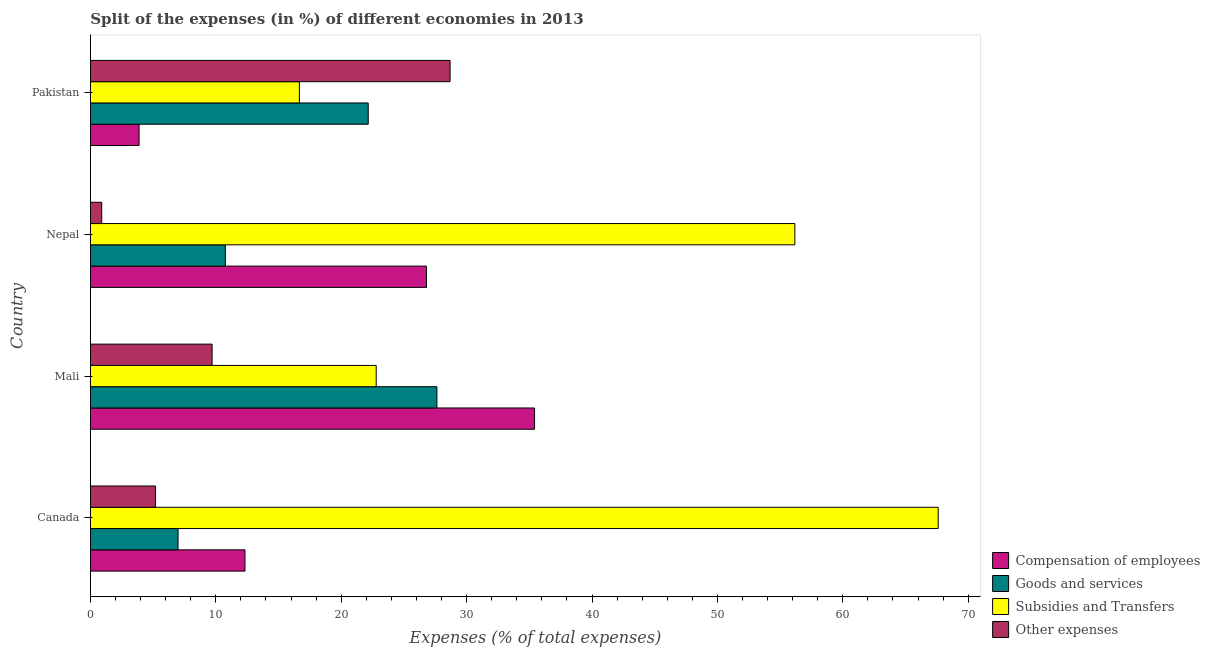How many different coloured bars are there?
Your answer should be compact. 4. How many groups of bars are there?
Provide a succinct answer. 4. Are the number of bars per tick equal to the number of legend labels?
Your answer should be very brief. Yes. How many bars are there on the 2nd tick from the bottom?
Provide a succinct answer. 4. What is the label of the 1st group of bars from the top?
Give a very brief answer. Pakistan. In how many cases, is the number of bars for a given country not equal to the number of legend labels?
Your answer should be compact. 0. What is the percentage of amount spent on subsidies in Pakistan?
Make the answer very short. 16.66. Across all countries, what is the maximum percentage of amount spent on subsidies?
Provide a succinct answer. 67.61. Across all countries, what is the minimum percentage of amount spent on goods and services?
Make the answer very short. 6.99. In which country was the percentage of amount spent on subsidies maximum?
Provide a short and direct response. Canada. What is the total percentage of amount spent on goods and services in the graph?
Provide a succinct answer. 67.55. What is the difference between the percentage of amount spent on compensation of employees in Canada and that in Nepal?
Ensure brevity in your answer.  -14.48. What is the difference between the percentage of amount spent on compensation of employees in Mali and the percentage of amount spent on other expenses in Nepal?
Your answer should be compact. 34.52. What is the average percentage of amount spent on subsidies per country?
Offer a terse response. 40.81. What is the difference between the percentage of amount spent on other expenses and percentage of amount spent on compensation of employees in Pakistan?
Your response must be concise. 24.8. What is the ratio of the percentage of amount spent on other expenses in Mali to that in Nepal?
Your response must be concise. 10.73. Is the difference between the percentage of amount spent on subsidies in Canada and Nepal greater than the difference between the percentage of amount spent on goods and services in Canada and Nepal?
Give a very brief answer. Yes. What is the difference between the highest and the second highest percentage of amount spent on goods and services?
Make the answer very short. 5.48. What is the difference between the highest and the lowest percentage of amount spent on subsidies?
Offer a very short reply. 50.94. Is it the case that in every country, the sum of the percentage of amount spent on goods and services and percentage of amount spent on compensation of employees is greater than the sum of percentage of amount spent on other expenses and percentage of amount spent on subsidies?
Provide a succinct answer. Yes. What does the 3rd bar from the top in Nepal represents?
Your answer should be very brief. Goods and services. What does the 3rd bar from the bottom in Nepal represents?
Make the answer very short. Subsidies and Transfers. How many bars are there?
Make the answer very short. 16. Are all the bars in the graph horizontal?
Offer a very short reply. Yes. What is the difference between two consecutive major ticks on the X-axis?
Provide a succinct answer. 10. Does the graph contain any zero values?
Offer a terse response. No. What is the title of the graph?
Provide a succinct answer. Split of the expenses (in %) of different economies in 2013. What is the label or title of the X-axis?
Ensure brevity in your answer.  Expenses (% of total expenses). What is the label or title of the Y-axis?
Keep it short and to the point. Country. What is the Expenses (% of total expenses) of Compensation of employees in Canada?
Offer a terse response. 12.33. What is the Expenses (% of total expenses) in Goods and services in Canada?
Provide a succinct answer. 6.99. What is the Expenses (% of total expenses) of Subsidies and Transfers in Canada?
Your answer should be compact. 67.61. What is the Expenses (% of total expenses) in Other expenses in Canada?
Ensure brevity in your answer.  5.2. What is the Expenses (% of total expenses) in Compensation of employees in Mali?
Provide a succinct answer. 35.42. What is the Expenses (% of total expenses) of Goods and services in Mali?
Offer a very short reply. 27.63. What is the Expenses (% of total expenses) of Subsidies and Transfers in Mali?
Offer a terse response. 22.79. What is the Expenses (% of total expenses) of Other expenses in Mali?
Give a very brief answer. 9.71. What is the Expenses (% of total expenses) in Compensation of employees in Nepal?
Your answer should be very brief. 26.8. What is the Expenses (% of total expenses) of Goods and services in Nepal?
Give a very brief answer. 10.76. What is the Expenses (% of total expenses) in Subsidies and Transfers in Nepal?
Your response must be concise. 56.17. What is the Expenses (% of total expenses) in Other expenses in Nepal?
Make the answer very short. 0.9. What is the Expenses (% of total expenses) of Compensation of employees in Pakistan?
Keep it short and to the point. 3.88. What is the Expenses (% of total expenses) of Goods and services in Pakistan?
Ensure brevity in your answer.  22.16. What is the Expenses (% of total expenses) of Subsidies and Transfers in Pakistan?
Give a very brief answer. 16.66. What is the Expenses (% of total expenses) in Other expenses in Pakistan?
Keep it short and to the point. 28.68. Across all countries, what is the maximum Expenses (% of total expenses) of Compensation of employees?
Offer a very short reply. 35.42. Across all countries, what is the maximum Expenses (% of total expenses) of Goods and services?
Offer a terse response. 27.63. Across all countries, what is the maximum Expenses (% of total expenses) in Subsidies and Transfers?
Ensure brevity in your answer.  67.61. Across all countries, what is the maximum Expenses (% of total expenses) in Other expenses?
Make the answer very short. 28.68. Across all countries, what is the minimum Expenses (% of total expenses) of Compensation of employees?
Give a very brief answer. 3.88. Across all countries, what is the minimum Expenses (% of total expenses) of Goods and services?
Give a very brief answer. 6.99. Across all countries, what is the minimum Expenses (% of total expenses) of Subsidies and Transfers?
Your answer should be compact. 16.66. Across all countries, what is the minimum Expenses (% of total expenses) of Other expenses?
Your answer should be compact. 0.9. What is the total Expenses (% of total expenses) of Compensation of employees in the graph?
Your answer should be compact. 78.44. What is the total Expenses (% of total expenses) of Goods and services in the graph?
Your answer should be compact. 67.55. What is the total Expenses (% of total expenses) of Subsidies and Transfers in the graph?
Make the answer very short. 163.24. What is the total Expenses (% of total expenses) in Other expenses in the graph?
Keep it short and to the point. 44.49. What is the difference between the Expenses (% of total expenses) of Compensation of employees in Canada and that in Mali?
Keep it short and to the point. -23.09. What is the difference between the Expenses (% of total expenses) of Goods and services in Canada and that in Mali?
Make the answer very short. -20.64. What is the difference between the Expenses (% of total expenses) of Subsidies and Transfers in Canada and that in Mali?
Offer a very short reply. 44.81. What is the difference between the Expenses (% of total expenses) of Other expenses in Canada and that in Mali?
Provide a short and direct response. -4.51. What is the difference between the Expenses (% of total expenses) in Compensation of employees in Canada and that in Nepal?
Your response must be concise. -14.48. What is the difference between the Expenses (% of total expenses) of Goods and services in Canada and that in Nepal?
Provide a succinct answer. -3.77. What is the difference between the Expenses (% of total expenses) in Subsidies and Transfers in Canada and that in Nepal?
Keep it short and to the point. 11.43. What is the difference between the Expenses (% of total expenses) of Other expenses in Canada and that in Nepal?
Give a very brief answer. 4.29. What is the difference between the Expenses (% of total expenses) of Compensation of employees in Canada and that in Pakistan?
Offer a terse response. 8.44. What is the difference between the Expenses (% of total expenses) in Goods and services in Canada and that in Pakistan?
Keep it short and to the point. -15.17. What is the difference between the Expenses (% of total expenses) of Subsidies and Transfers in Canada and that in Pakistan?
Your answer should be compact. 50.94. What is the difference between the Expenses (% of total expenses) in Other expenses in Canada and that in Pakistan?
Your response must be concise. -23.49. What is the difference between the Expenses (% of total expenses) of Compensation of employees in Mali and that in Nepal?
Your answer should be compact. 8.62. What is the difference between the Expenses (% of total expenses) in Goods and services in Mali and that in Nepal?
Provide a short and direct response. 16.87. What is the difference between the Expenses (% of total expenses) of Subsidies and Transfers in Mali and that in Nepal?
Your answer should be compact. -33.38. What is the difference between the Expenses (% of total expenses) of Other expenses in Mali and that in Nepal?
Keep it short and to the point. 8.8. What is the difference between the Expenses (% of total expenses) in Compensation of employees in Mali and that in Pakistan?
Provide a succinct answer. 31.54. What is the difference between the Expenses (% of total expenses) in Goods and services in Mali and that in Pakistan?
Offer a very short reply. 5.48. What is the difference between the Expenses (% of total expenses) in Subsidies and Transfers in Mali and that in Pakistan?
Ensure brevity in your answer.  6.13. What is the difference between the Expenses (% of total expenses) of Other expenses in Mali and that in Pakistan?
Your response must be concise. -18.98. What is the difference between the Expenses (% of total expenses) in Compensation of employees in Nepal and that in Pakistan?
Offer a very short reply. 22.92. What is the difference between the Expenses (% of total expenses) of Goods and services in Nepal and that in Pakistan?
Keep it short and to the point. -11.39. What is the difference between the Expenses (% of total expenses) of Subsidies and Transfers in Nepal and that in Pakistan?
Provide a succinct answer. 39.51. What is the difference between the Expenses (% of total expenses) of Other expenses in Nepal and that in Pakistan?
Provide a short and direct response. -27.78. What is the difference between the Expenses (% of total expenses) in Compensation of employees in Canada and the Expenses (% of total expenses) in Goods and services in Mali?
Offer a terse response. -15.31. What is the difference between the Expenses (% of total expenses) of Compensation of employees in Canada and the Expenses (% of total expenses) of Subsidies and Transfers in Mali?
Provide a short and direct response. -10.46. What is the difference between the Expenses (% of total expenses) of Compensation of employees in Canada and the Expenses (% of total expenses) of Other expenses in Mali?
Provide a short and direct response. 2.62. What is the difference between the Expenses (% of total expenses) in Goods and services in Canada and the Expenses (% of total expenses) in Subsidies and Transfers in Mali?
Give a very brief answer. -15.8. What is the difference between the Expenses (% of total expenses) of Goods and services in Canada and the Expenses (% of total expenses) of Other expenses in Mali?
Your answer should be very brief. -2.71. What is the difference between the Expenses (% of total expenses) in Subsidies and Transfers in Canada and the Expenses (% of total expenses) in Other expenses in Mali?
Provide a succinct answer. 57.9. What is the difference between the Expenses (% of total expenses) of Compensation of employees in Canada and the Expenses (% of total expenses) of Goods and services in Nepal?
Your answer should be very brief. 1.56. What is the difference between the Expenses (% of total expenses) of Compensation of employees in Canada and the Expenses (% of total expenses) of Subsidies and Transfers in Nepal?
Offer a terse response. -43.85. What is the difference between the Expenses (% of total expenses) of Compensation of employees in Canada and the Expenses (% of total expenses) of Other expenses in Nepal?
Your answer should be compact. 11.42. What is the difference between the Expenses (% of total expenses) of Goods and services in Canada and the Expenses (% of total expenses) of Subsidies and Transfers in Nepal?
Give a very brief answer. -49.18. What is the difference between the Expenses (% of total expenses) of Goods and services in Canada and the Expenses (% of total expenses) of Other expenses in Nepal?
Ensure brevity in your answer.  6.09. What is the difference between the Expenses (% of total expenses) in Subsidies and Transfers in Canada and the Expenses (% of total expenses) in Other expenses in Nepal?
Provide a succinct answer. 66.7. What is the difference between the Expenses (% of total expenses) of Compensation of employees in Canada and the Expenses (% of total expenses) of Goods and services in Pakistan?
Give a very brief answer. -9.83. What is the difference between the Expenses (% of total expenses) in Compensation of employees in Canada and the Expenses (% of total expenses) in Subsidies and Transfers in Pakistan?
Keep it short and to the point. -4.34. What is the difference between the Expenses (% of total expenses) of Compensation of employees in Canada and the Expenses (% of total expenses) of Other expenses in Pakistan?
Your answer should be compact. -16.36. What is the difference between the Expenses (% of total expenses) in Goods and services in Canada and the Expenses (% of total expenses) in Subsidies and Transfers in Pakistan?
Provide a succinct answer. -9.67. What is the difference between the Expenses (% of total expenses) in Goods and services in Canada and the Expenses (% of total expenses) in Other expenses in Pakistan?
Offer a very short reply. -21.69. What is the difference between the Expenses (% of total expenses) of Subsidies and Transfers in Canada and the Expenses (% of total expenses) of Other expenses in Pakistan?
Offer a terse response. 38.92. What is the difference between the Expenses (% of total expenses) in Compensation of employees in Mali and the Expenses (% of total expenses) in Goods and services in Nepal?
Give a very brief answer. 24.66. What is the difference between the Expenses (% of total expenses) of Compensation of employees in Mali and the Expenses (% of total expenses) of Subsidies and Transfers in Nepal?
Keep it short and to the point. -20.75. What is the difference between the Expenses (% of total expenses) of Compensation of employees in Mali and the Expenses (% of total expenses) of Other expenses in Nepal?
Make the answer very short. 34.52. What is the difference between the Expenses (% of total expenses) of Goods and services in Mali and the Expenses (% of total expenses) of Subsidies and Transfers in Nepal?
Provide a short and direct response. -28.54. What is the difference between the Expenses (% of total expenses) of Goods and services in Mali and the Expenses (% of total expenses) of Other expenses in Nepal?
Ensure brevity in your answer.  26.73. What is the difference between the Expenses (% of total expenses) of Subsidies and Transfers in Mali and the Expenses (% of total expenses) of Other expenses in Nepal?
Give a very brief answer. 21.89. What is the difference between the Expenses (% of total expenses) in Compensation of employees in Mali and the Expenses (% of total expenses) in Goods and services in Pakistan?
Your response must be concise. 13.26. What is the difference between the Expenses (% of total expenses) in Compensation of employees in Mali and the Expenses (% of total expenses) in Subsidies and Transfers in Pakistan?
Provide a short and direct response. 18.76. What is the difference between the Expenses (% of total expenses) of Compensation of employees in Mali and the Expenses (% of total expenses) of Other expenses in Pakistan?
Your answer should be very brief. 6.74. What is the difference between the Expenses (% of total expenses) in Goods and services in Mali and the Expenses (% of total expenses) in Subsidies and Transfers in Pakistan?
Keep it short and to the point. 10.97. What is the difference between the Expenses (% of total expenses) of Goods and services in Mali and the Expenses (% of total expenses) of Other expenses in Pakistan?
Offer a terse response. -1.05. What is the difference between the Expenses (% of total expenses) in Subsidies and Transfers in Mali and the Expenses (% of total expenses) in Other expenses in Pakistan?
Your response must be concise. -5.89. What is the difference between the Expenses (% of total expenses) in Compensation of employees in Nepal and the Expenses (% of total expenses) in Goods and services in Pakistan?
Offer a very short reply. 4.65. What is the difference between the Expenses (% of total expenses) of Compensation of employees in Nepal and the Expenses (% of total expenses) of Subsidies and Transfers in Pakistan?
Offer a very short reply. 10.14. What is the difference between the Expenses (% of total expenses) in Compensation of employees in Nepal and the Expenses (% of total expenses) in Other expenses in Pakistan?
Ensure brevity in your answer.  -1.88. What is the difference between the Expenses (% of total expenses) in Goods and services in Nepal and the Expenses (% of total expenses) in Subsidies and Transfers in Pakistan?
Your answer should be compact. -5.9. What is the difference between the Expenses (% of total expenses) of Goods and services in Nepal and the Expenses (% of total expenses) of Other expenses in Pakistan?
Your response must be concise. -17.92. What is the difference between the Expenses (% of total expenses) of Subsidies and Transfers in Nepal and the Expenses (% of total expenses) of Other expenses in Pakistan?
Give a very brief answer. 27.49. What is the average Expenses (% of total expenses) in Compensation of employees per country?
Your answer should be very brief. 19.61. What is the average Expenses (% of total expenses) of Goods and services per country?
Provide a short and direct response. 16.89. What is the average Expenses (% of total expenses) in Subsidies and Transfers per country?
Offer a very short reply. 40.81. What is the average Expenses (% of total expenses) in Other expenses per country?
Your answer should be compact. 11.12. What is the difference between the Expenses (% of total expenses) in Compensation of employees and Expenses (% of total expenses) in Goods and services in Canada?
Provide a succinct answer. 5.34. What is the difference between the Expenses (% of total expenses) in Compensation of employees and Expenses (% of total expenses) in Subsidies and Transfers in Canada?
Give a very brief answer. -55.28. What is the difference between the Expenses (% of total expenses) in Compensation of employees and Expenses (% of total expenses) in Other expenses in Canada?
Provide a short and direct response. 7.13. What is the difference between the Expenses (% of total expenses) in Goods and services and Expenses (% of total expenses) in Subsidies and Transfers in Canada?
Offer a terse response. -60.61. What is the difference between the Expenses (% of total expenses) in Goods and services and Expenses (% of total expenses) in Other expenses in Canada?
Make the answer very short. 1.8. What is the difference between the Expenses (% of total expenses) in Subsidies and Transfers and Expenses (% of total expenses) in Other expenses in Canada?
Provide a succinct answer. 62.41. What is the difference between the Expenses (% of total expenses) of Compensation of employees and Expenses (% of total expenses) of Goods and services in Mali?
Your answer should be compact. 7.79. What is the difference between the Expenses (% of total expenses) of Compensation of employees and Expenses (% of total expenses) of Subsidies and Transfers in Mali?
Your answer should be compact. 12.63. What is the difference between the Expenses (% of total expenses) of Compensation of employees and Expenses (% of total expenses) of Other expenses in Mali?
Ensure brevity in your answer.  25.71. What is the difference between the Expenses (% of total expenses) of Goods and services and Expenses (% of total expenses) of Subsidies and Transfers in Mali?
Your response must be concise. 4.84. What is the difference between the Expenses (% of total expenses) of Goods and services and Expenses (% of total expenses) of Other expenses in Mali?
Your answer should be compact. 17.93. What is the difference between the Expenses (% of total expenses) of Subsidies and Transfers and Expenses (% of total expenses) of Other expenses in Mali?
Make the answer very short. 13.09. What is the difference between the Expenses (% of total expenses) in Compensation of employees and Expenses (% of total expenses) in Goods and services in Nepal?
Provide a succinct answer. 16.04. What is the difference between the Expenses (% of total expenses) of Compensation of employees and Expenses (% of total expenses) of Subsidies and Transfers in Nepal?
Make the answer very short. -29.37. What is the difference between the Expenses (% of total expenses) in Compensation of employees and Expenses (% of total expenses) in Other expenses in Nepal?
Your response must be concise. 25.9. What is the difference between the Expenses (% of total expenses) of Goods and services and Expenses (% of total expenses) of Subsidies and Transfers in Nepal?
Your answer should be compact. -45.41. What is the difference between the Expenses (% of total expenses) of Goods and services and Expenses (% of total expenses) of Other expenses in Nepal?
Keep it short and to the point. 9.86. What is the difference between the Expenses (% of total expenses) in Subsidies and Transfers and Expenses (% of total expenses) in Other expenses in Nepal?
Your response must be concise. 55.27. What is the difference between the Expenses (% of total expenses) in Compensation of employees and Expenses (% of total expenses) in Goods and services in Pakistan?
Make the answer very short. -18.27. What is the difference between the Expenses (% of total expenses) of Compensation of employees and Expenses (% of total expenses) of Subsidies and Transfers in Pakistan?
Your response must be concise. -12.78. What is the difference between the Expenses (% of total expenses) in Compensation of employees and Expenses (% of total expenses) in Other expenses in Pakistan?
Your answer should be compact. -24.8. What is the difference between the Expenses (% of total expenses) in Goods and services and Expenses (% of total expenses) in Subsidies and Transfers in Pakistan?
Your answer should be compact. 5.49. What is the difference between the Expenses (% of total expenses) in Goods and services and Expenses (% of total expenses) in Other expenses in Pakistan?
Your answer should be very brief. -6.53. What is the difference between the Expenses (% of total expenses) in Subsidies and Transfers and Expenses (% of total expenses) in Other expenses in Pakistan?
Provide a succinct answer. -12.02. What is the ratio of the Expenses (% of total expenses) of Compensation of employees in Canada to that in Mali?
Provide a short and direct response. 0.35. What is the ratio of the Expenses (% of total expenses) of Goods and services in Canada to that in Mali?
Your response must be concise. 0.25. What is the ratio of the Expenses (% of total expenses) of Subsidies and Transfers in Canada to that in Mali?
Give a very brief answer. 2.97. What is the ratio of the Expenses (% of total expenses) in Other expenses in Canada to that in Mali?
Your response must be concise. 0.54. What is the ratio of the Expenses (% of total expenses) of Compensation of employees in Canada to that in Nepal?
Your answer should be compact. 0.46. What is the ratio of the Expenses (% of total expenses) of Goods and services in Canada to that in Nepal?
Ensure brevity in your answer.  0.65. What is the ratio of the Expenses (% of total expenses) in Subsidies and Transfers in Canada to that in Nepal?
Offer a very short reply. 1.2. What is the ratio of the Expenses (% of total expenses) of Other expenses in Canada to that in Nepal?
Ensure brevity in your answer.  5.74. What is the ratio of the Expenses (% of total expenses) in Compensation of employees in Canada to that in Pakistan?
Keep it short and to the point. 3.17. What is the ratio of the Expenses (% of total expenses) in Goods and services in Canada to that in Pakistan?
Keep it short and to the point. 0.32. What is the ratio of the Expenses (% of total expenses) in Subsidies and Transfers in Canada to that in Pakistan?
Your answer should be compact. 4.06. What is the ratio of the Expenses (% of total expenses) of Other expenses in Canada to that in Pakistan?
Offer a very short reply. 0.18. What is the ratio of the Expenses (% of total expenses) in Compensation of employees in Mali to that in Nepal?
Provide a succinct answer. 1.32. What is the ratio of the Expenses (% of total expenses) in Goods and services in Mali to that in Nepal?
Your answer should be very brief. 2.57. What is the ratio of the Expenses (% of total expenses) of Subsidies and Transfers in Mali to that in Nepal?
Your answer should be compact. 0.41. What is the ratio of the Expenses (% of total expenses) of Other expenses in Mali to that in Nepal?
Provide a succinct answer. 10.73. What is the ratio of the Expenses (% of total expenses) in Compensation of employees in Mali to that in Pakistan?
Your response must be concise. 9.12. What is the ratio of the Expenses (% of total expenses) of Goods and services in Mali to that in Pakistan?
Offer a terse response. 1.25. What is the ratio of the Expenses (% of total expenses) in Subsidies and Transfers in Mali to that in Pakistan?
Give a very brief answer. 1.37. What is the ratio of the Expenses (% of total expenses) of Other expenses in Mali to that in Pakistan?
Keep it short and to the point. 0.34. What is the ratio of the Expenses (% of total expenses) of Compensation of employees in Nepal to that in Pakistan?
Offer a very short reply. 6.9. What is the ratio of the Expenses (% of total expenses) in Goods and services in Nepal to that in Pakistan?
Keep it short and to the point. 0.49. What is the ratio of the Expenses (% of total expenses) of Subsidies and Transfers in Nepal to that in Pakistan?
Offer a terse response. 3.37. What is the ratio of the Expenses (% of total expenses) of Other expenses in Nepal to that in Pakistan?
Make the answer very short. 0.03. What is the difference between the highest and the second highest Expenses (% of total expenses) in Compensation of employees?
Keep it short and to the point. 8.62. What is the difference between the highest and the second highest Expenses (% of total expenses) in Goods and services?
Your answer should be compact. 5.48. What is the difference between the highest and the second highest Expenses (% of total expenses) of Subsidies and Transfers?
Provide a succinct answer. 11.43. What is the difference between the highest and the second highest Expenses (% of total expenses) in Other expenses?
Make the answer very short. 18.98. What is the difference between the highest and the lowest Expenses (% of total expenses) of Compensation of employees?
Ensure brevity in your answer.  31.54. What is the difference between the highest and the lowest Expenses (% of total expenses) of Goods and services?
Your answer should be very brief. 20.64. What is the difference between the highest and the lowest Expenses (% of total expenses) in Subsidies and Transfers?
Give a very brief answer. 50.94. What is the difference between the highest and the lowest Expenses (% of total expenses) in Other expenses?
Provide a succinct answer. 27.78. 